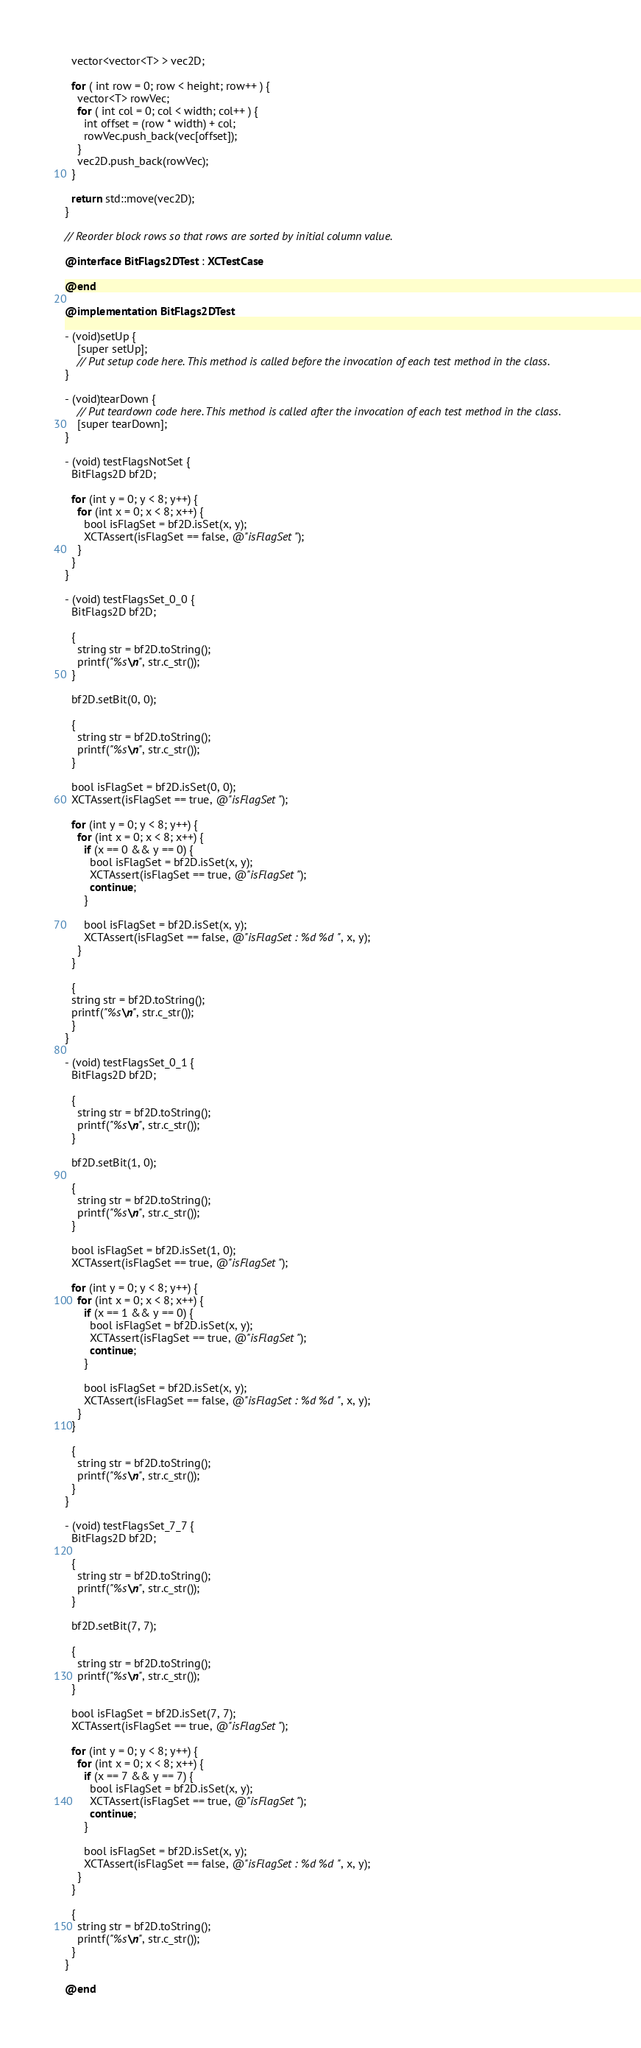<code> <loc_0><loc_0><loc_500><loc_500><_ObjectiveC_>  vector<vector<T> > vec2D;
  
  for ( int row = 0; row < height; row++ ) {
    vector<T> rowVec;
    for ( int col = 0; col < width; col++ ) {
      int offset = (row * width) + col;
      rowVec.push_back(vec[offset]);
    }
    vec2D.push_back(rowVec);
  }
  
  return std::move(vec2D);
}

// Reorder block rows so that rows are sorted by initial column value.

@interface BitFlags2DTest : XCTestCase

@end

@implementation BitFlags2DTest

- (void)setUp {
    [super setUp];
    // Put setup code here. This method is called before the invocation of each test method in the class.
}

- (void)tearDown {
    // Put teardown code here. This method is called after the invocation of each test method in the class.
    [super tearDown];
}

- (void) testFlagsNotSet {
  BitFlags2D bf2D;
  
  for (int y = 0; y < 8; y++) {
    for (int x = 0; x < 8; x++) {
      bool isFlagSet = bf2D.isSet(x, y);
      XCTAssert(isFlagSet == false, @"isFlagSet");
    }
  }
}

- (void) testFlagsSet_0_0 {
  BitFlags2D bf2D;

  {
    string str = bf2D.toString();
    printf("%s\n", str.c_str());
  }
  
  bf2D.setBit(0, 0);
  
  {
    string str = bf2D.toString();
    printf("%s\n", str.c_str());
  }
  
  bool isFlagSet = bf2D.isSet(0, 0);
  XCTAssert(isFlagSet == true, @"isFlagSet");
  
  for (int y = 0; y < 8; y++) {
    for (int x = 0; x < 8; x++) {
      if (x == 0 && y == 0) {
        bool isFlagSet = bf2D.isSet(x, y);
        XCTAssert(isFlagSet == true, @"isFlagSet");
        continue;
      }
      
      bool isFlagSet = bf2D.isSet(x, y);
      XCTAssert(isFlagSet == false, @"isFlagSet : %d %d", x, y);
    }
  }
  
  {
  string str = bf2D.toString();
  printf("%s\n", str.c_str());
  }
}

- (void) testFlagsSet_0_1 {
  BitFlags2D bf2D;
  
  {
    string str = bf2D.toString();
    printf("%s\n", str.c_str());
  }
  
  bf2D.setBit(1, 0);
  
  {
    string str = bf2D.toString();
    printf("%s\n", str.c_str());
  }
  
  bool isFlagSet = bf2D.isSet(1, 0);
  XCTAssert(isFlagSet == true, @"isFlagSet");
  
  for (int y = 0; y < 8; y++) {
    for (int x = 0; x < 8; x++) {
      if (x == 1 && y == 0) {
        bool isFlagSet = bf2D.isSet(x, y);
        XCTAssert(isFlagSet == true, @"isFlagSet");
        continue;
      }
      
      bool isFlagSet = bf2D.isSet(x, y);
      XCTAssert(isFlagSet == false, @"isFlagSet : %d %d", x, y);
    }
  }
  
  {
    string str = bf2D.toString();
    printf("%s\n", str.c_str());
  }
}

- (void) testFlagsSet_7_7 {
  BitFlags2D bf2D;
  
  {
    string str = bf2D.toString();
    printf("%s\n", str.c_str());
  }
  
  bf2D.setBit(7, 7);
  
  {
    string str = bf2D.toString();
    printf("%s\n", str.c_str());
  }
  
  bool isFlagSet = bf2D.isSet(7, 7);
  XCTAssert(isFlagSet == true, @"isFlagSet");
  
  for (int y = 0; y < 8; y++) {
    for (int x = 0; x < 8; x++) {
      if (x == 7 && y == 7) {
        bool isFlagSet = bf2D.isSet(x, y);
        XCTAssert(isFlagSet == true, @"isFlagSet");
        continue;
      }
      
      bool isFlagSet = bf2D.isSet(x, y);
      XCTAssert(isFlagSet == false, @"isFlagSet : %d %d", x, y);
    }
  }
  
  {
    string str = bf2D.toString();
    printf("%s\n", str.c_str());
  }
}

@end

</code> 